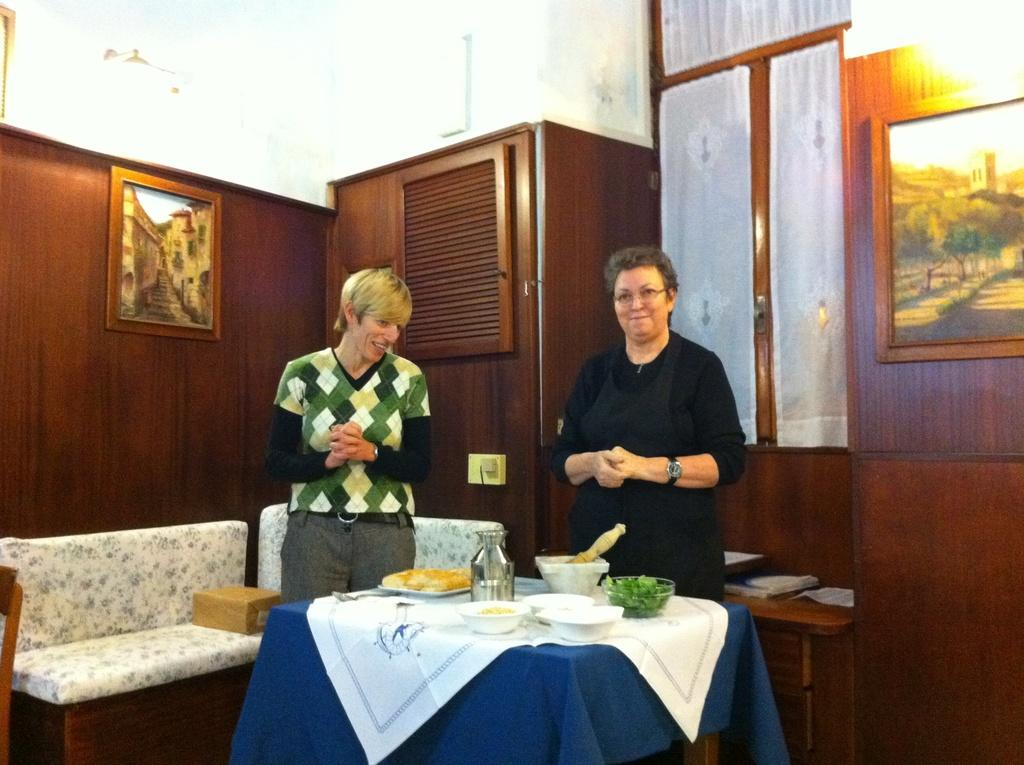What is the woman on the right side of the image doing? The woman is standing on the right side of the image and smiling. What is the woman wearing in the image? The woman is wearing a black dress in the image. Who else is present in the image? There is another person standing on the left side of the image. What can be seen on the wall in the image? There is a photo frame on the wall in the image. How many snakes are slithering on the floor in the image? There are no snakes present in the image. What direction does the board point to in the image? There is no board present in the image. 